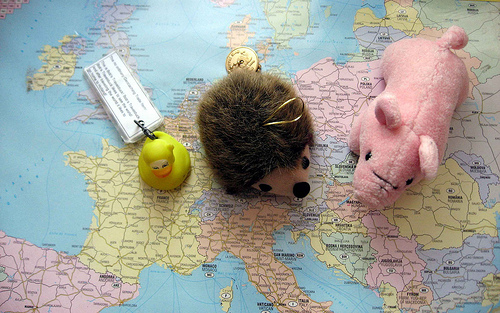<image>
Can you confirm if the duck is on the france? Yes. Looking at the image, I can see the duck is positioned on top of the france, with the france providing support. Is the pig on the map? Yes. Looking at the image, I can see the pig is positioned on top of the map, with the map providing support. Is the hedgehog on the map? Yes. Looking at the image, I can see the hedgehog is positioned on top of the map, with the map providing support. 